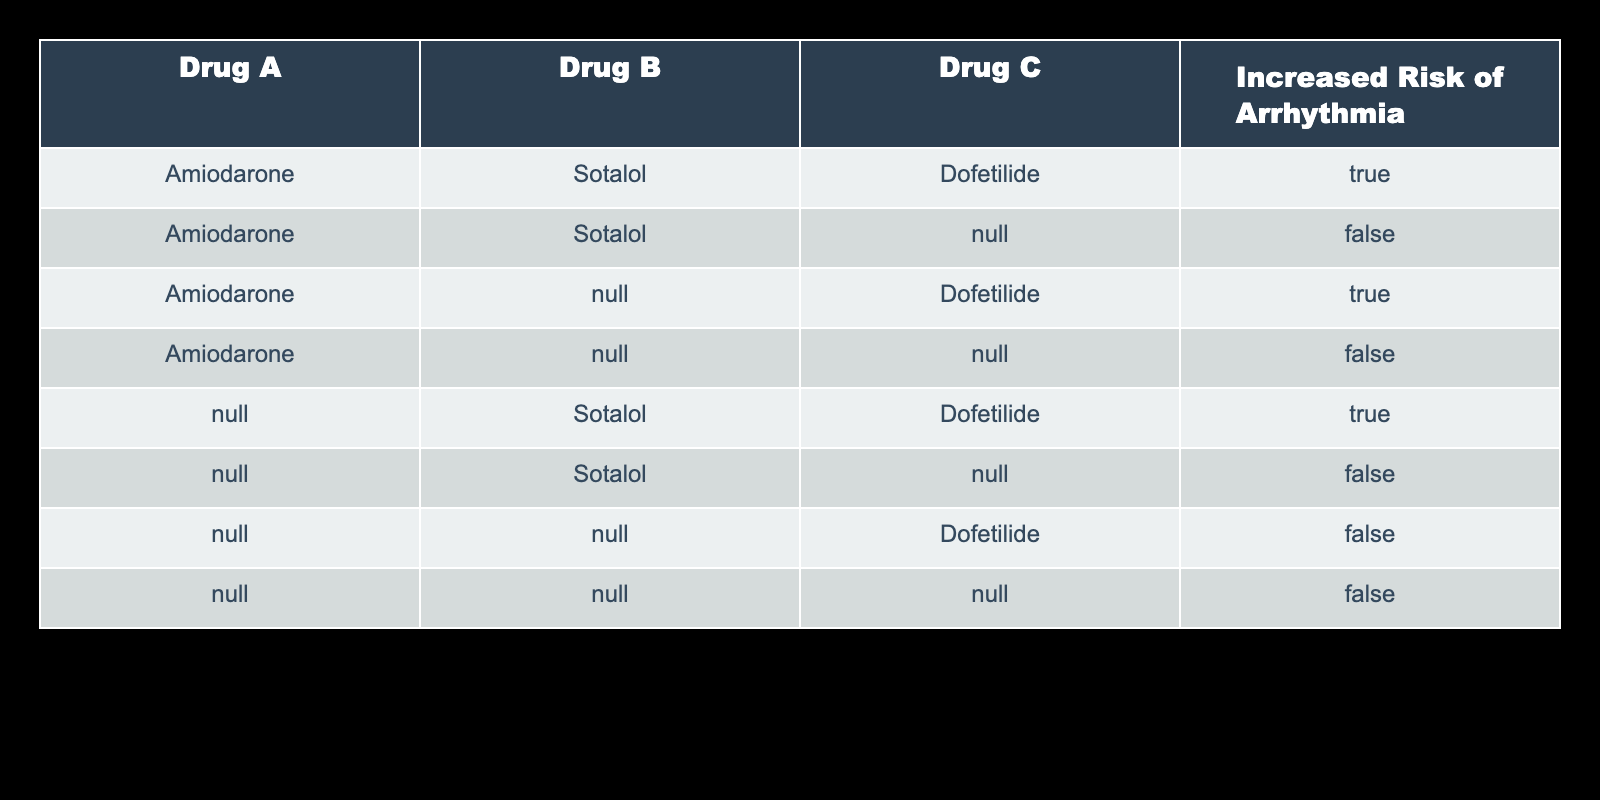What is the value for increased risk of arrhythmia when Drug A is Amiodarone, Drug B is Sotalol, and Drug C is Dofetilide? Referring to the table, for the specific combination of Amiodarone, Sotalol, and Dofetilide, the value for increased risk of arrhythmia is TRUE.
Answer: TRUE How many total combinations are evaluated for increased risk of arrhythmia? By counting the rows in the table, there are 8 total combinations listed for the evaluation of the increased risk of arrhythmia.
Answer: 8 What is the increased risk of arrhythmia when Drug A is Amiodarone and Drug B is Sotalol? From the table, when Drug A is Amiodarone and Drug B is Sotalol (with no Drug C specified), the risk of arrhythmia is FALSE.
Answer: FALSE How many combinations indicate an increased risk of arrhythmia? Analyzing the data in the table, there are 4 combinations that indicate an increased risk of arrhythmia (including the combinations with Drug C). Counting these specific rows gives the answer.
Answer: 4 Is there any combination with only Drug C being Dofetilide that leads to an increased risk of arrhythmia? Looking at the table, when Drug A and Drug B are not specified, but Drug C is Dofetilide, the increased risk of arrhythmia is TRUE, indicating that this specific combination does pose an increased risk.
Answer: TRUE What is the increased risk of arrhythmia for the combination of Sotalol and Dofetilide only? When evaluating the combination of Sotalol and Dofetilide with no Drug A specified, the table shows that the increased risk of arrhythmia is TRUE.
Answer: TRUE Determine the combinations with no drugs specified. What is the risk of arrhythmia? The last row in the table shows the scenario with no drugs specified, which indicates the risk of arrhythmia as FALSE. Therefore, this specific combination does not pose any risk.
Answer: FALSE What can be inferred about the combination of Sotalol alone without any other drugs regarding arrhythmia risk? The table indicates that if only Drug B is Sotalol (with no other drugs), the risk of arrhythmia is FALSE. This suggests that Sotalol alone does not contribute to increased risk.
Answer: FALSE 